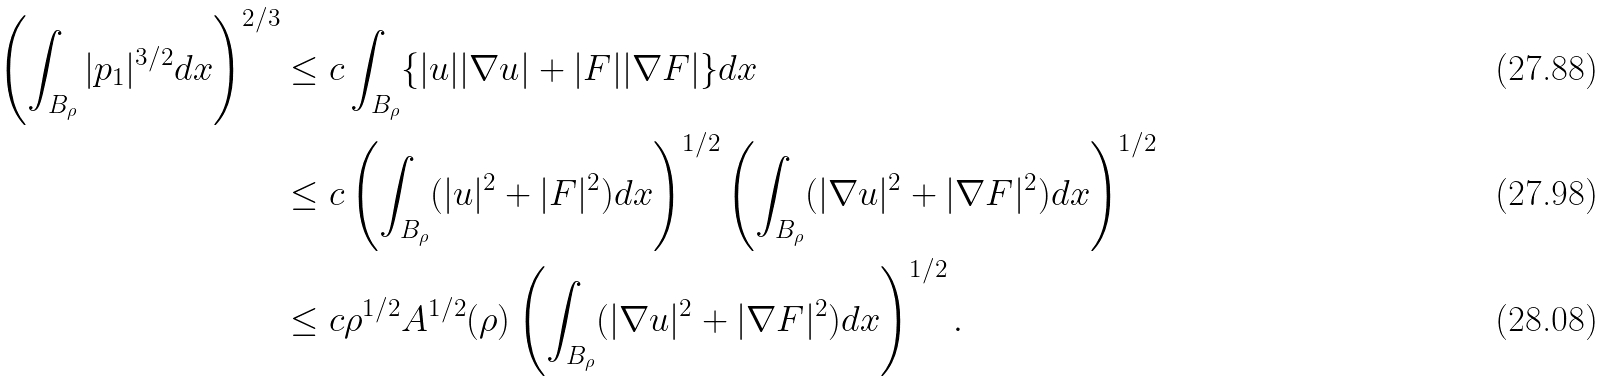<formula> <loc_0><loc_0><loc_500><loc_500>\left ( \int _ { B _ { \rho } } | p _ { 1 } | ^ { 3 / 2 } d x \right ) ^ { 2 / 3 } & \leq c \int _ { B _ { \rho } } \{ | u | | \nabla u | + | F | | \nabla F | \} d x \\ & \leq c \left ( \int _ { B _ { \rho } } ( | u | ^ { 2 } + | F | ^ { 2 } ) d x \right ) ^ { 1 / 2 } \left ( \int _ { B _ { \rho } } ( | \nabla u | ^ { 2 } + | \nabla F | ^ { 2 } ) d x \right ) ^ { 1 / 2 } \\ & \leq c \rho ^ { 1 / 2 } A ^ { 1 / 2 } ( \rho ) \left ( \int _ { B _ { \rho } } ( | \nabla u | ^ { 2 } + | \nabla F | ^ { 2 } ) d x \right ) ^ { 1 / 2 } .</formula> 